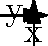Consider the vector field $\mathbf{F}(x,y) = (-0.2xe^{-0.1(x^2+y^2)}, -0.2ye^{-0.1(x^2+y^2)})$ representing the spread of cultural influence in a region during the migration period. The contour lines show the strength of cultural influence $f(x,y) = e^{-0.1(x^2+y^2)}$. Determine the direction of fastest increase in cultural influence at the point (2, 2) and explain its historical significance. To find the direction of fastest increase in cultural influence, we need to calculate the gradient of $f(x,y)$ at the point (2, 2).

Step 1: Calculate the partial derivatives of $f(x,y)$:
$$\frac{\partial f}{\partial x} = -0.2xe^{-0.1(x^2+y^2)}$$
$$\frac{\partial f}{\partial y} = -0.2ye^{-0.1(x^2+y^2)}$$

Step 2: The gradient is given by:
$$\nabla f(x,y) = \left(\frac{\partial f}{\partial x}, \frac{\partial f}{\partial y}\right) = (-0.2xe^{-0.1(x^2+y^2)}, -0.2ye^{-0.1(x^2+y^2)})$$

Step 3: Evaluate the gradient at (2, 2):
$$\nabla f(2,2) = (-0.2 \cdot 2e^{-0.1(2^2+2^2)}, -0.2 \cdot 2e^{-0.1(2^2+2^2)}) \approx (-0.1097, -0.1097)$$

Step 4: The direction of fastest increase is opposite to the gradient vector. Therefore, the direction of fastest increase is:
$$(0.1097, 0.1097)$$

Historical significance: This result indicates that the cultural influence is spreading most rapidly towards the center (0, 0) from the point (2, 2). In the context of the migration period, this could represent the diffusion of ideas, technologies, or customs from peripheral regions towards a central cultural hub. This pattern might reflect the movement of peoples or the exchange of knowledge along trade routes, contributing to the complex cultural interactions characteristic of the Dark Ages.
Answer: $(0.1097, 0.1097)$, towards the center 